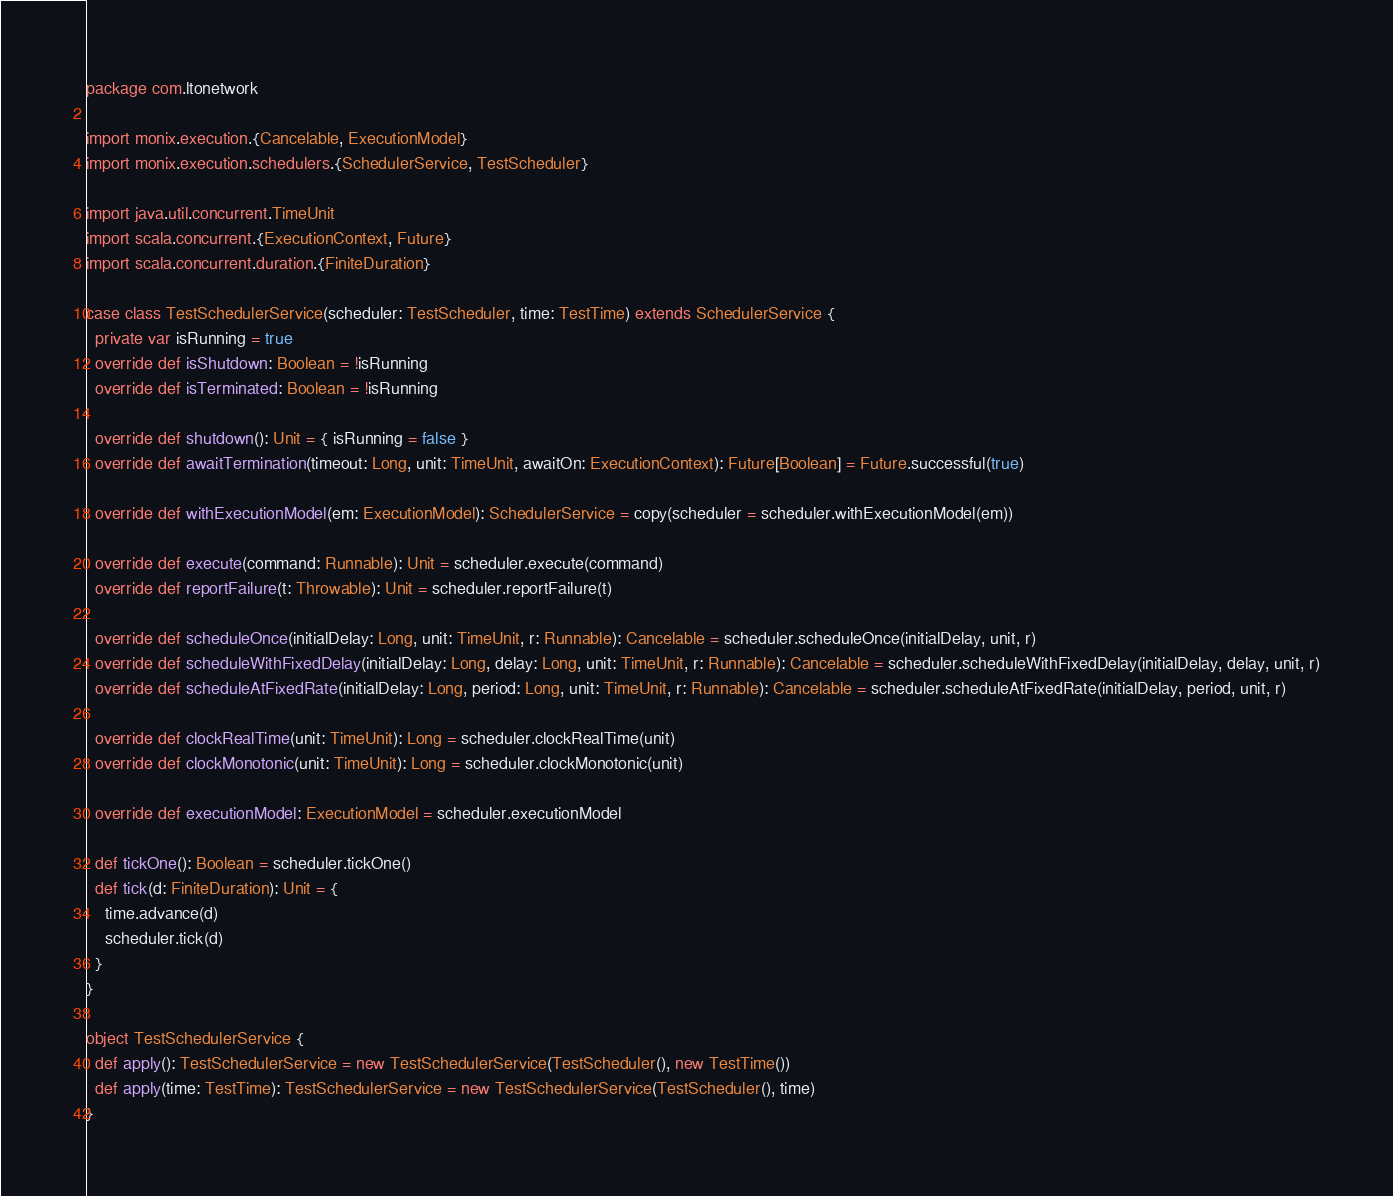Convert code to text. <code><loc_0><loc_0><loc_500><loc_500><_Scala_>package com.ltonetwork

import monix.execution.{Cancelable, ExecutionModel}
import monix.execution.schedulers.{SchedulerService, TestScheduler}

import java.util.concurrent.TimeUnit
import scala.concurrent.{ExecutionContext, Future}
import scala.concurrent.duration.{FiniteDuration}

case class TestSchedulerService(scheduler: TestScheduler, time: TestTime) extends SchedulerService {
  private var isRunning = true
  override def isShutdown: Boolean = !isRunning
  override def isTerminated: Boolean = !isRunning

  override def shutdown(): Unit = { isRunning = false }
  override def awaitTermination(timeout: Long, unit: TimeUnit, awaitOn: ExecutionContext): Future[Boolean] = Future.successful(true)

  override def withExecutionModel(em: ExecutionModel): SchedulerService = copy(scheduler = scheduler.withExecutionModel(em))

  override def execute(command: Runnable): Unit = scheduler.execute(command)
  override def reportFailure(t: Throwable): Unit = scheduler.reportFailure(t)

  override def scheduleOnce(initialDelay: Long, unit: TimeUnit, r: Runnable): Cancelable = scheduler.scheduleOnce(initialDelay, unit, r)
  override def scheduleWithFixedDelay(initialDelay: Long, delay: Long, unit: TimeUnit, r: Runnable): Cancelable = scheduler.scheduleWithFixedDelay(initialDelay, delay, unit, r)
  override def scheduleAtFixedRate(initialDelay: Long, period: Long, unit: TimeUnit, r: Runnable): Cancelable = scheduler.scheduleAtFixedRate(initialDelay, period, unit, r)

  override def clockRealTime(unit: TimeUnit): Long = scheduler.clockRealTime(unit)
  override def clockMonotonic(unit: TimeUnit): Long = scheduler.clockMonotonic(unit)

  override def executionModel: ExecutionModel = scheduler.executionModel

  def tickOne(): Boolean = scheduler.tickOne()
  def tick(d: FiniteDuration): Unit = {
    time.advance(d)
    scheduler.tick(d)
  }
}

object TestSchedulerService {
  def apply(): TestSchedulerService = new TestSchedulerService(TestScheduler(), new TestTime())
  def apply(time: TestTime): TestSchedulerService = new TestSchedulerService(TestScheduler(), time)
}
</code> 